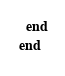Convert code to text. <code><loc_0><loc_0><loc_500><loc_500><_Ruby_>  end
end
</code> 